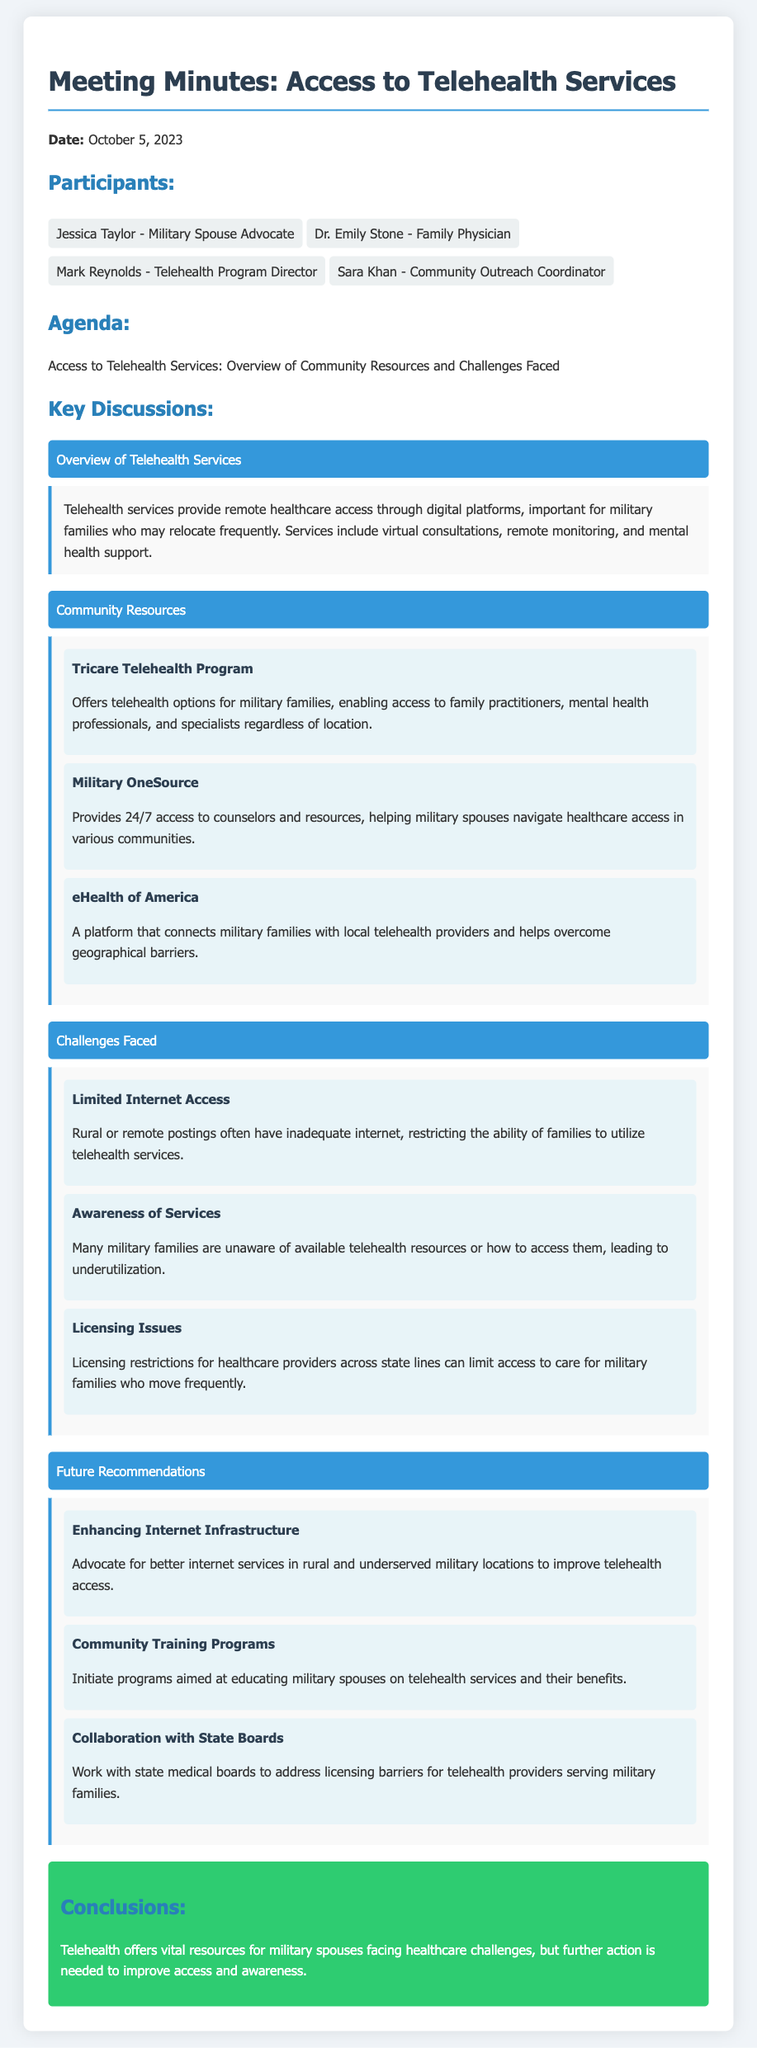What is the date of the meeting? The date of the meeting is explicitly mentioned at the start of the document.
Answer: October 5, 2023 Who is the Community Outreach Coordinator? The document lists participants and their roles, including the Community Outreach Coordinator.
Answer: Sara Khan What telehealth program is offered for military families? The meeting minutes provide details about specific programs available for military families.
Answer: Tricare Telehealth Program What challenge is associated with internet access? The document outlines various challenges faced in accessing telehealth services, including a specific challenge related to internet access.
Answer: Limited Internet Access What is one recommendation for improving telehealth access? Recommendations for addressing challenges in telehealth access are provided, including specific initiatives.
Answer: Enhancing Internet Infrastructure How many key discussions are listed in the minutes? The number of key discussions can be counted in the document where sections are titled.
Answer: Three What type of professionals can families access through the Tricare Telehealth Program? The document mentions the types of healthcare professionals accessible through this telehealth program.
Answer: Family practitioners, mental health professionals, and specialists What is a significant barrier regarding healthcare provider licensing? The challenges section details licensing issues affecting military families’ access to healthcare.
Answer: Licensing Issues 